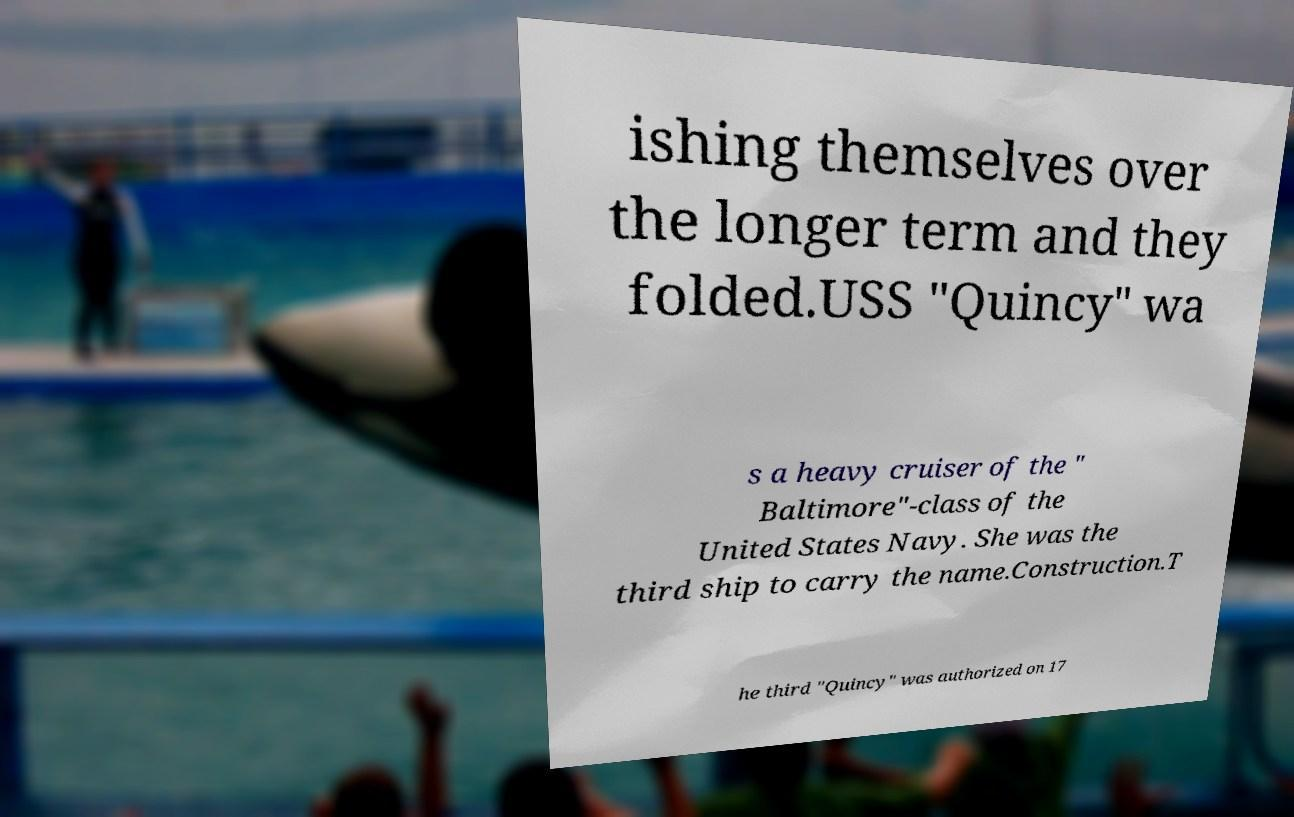Could you extract and type out the text from this image? ishing themselves over the longer term and they folded.USS "Quincy" wa s a heavy cruiser of the " Baltimore"-class of the United States Navy. She was the third ship to carry the name.Construction.T he third "Quincy" was authorized on 17 